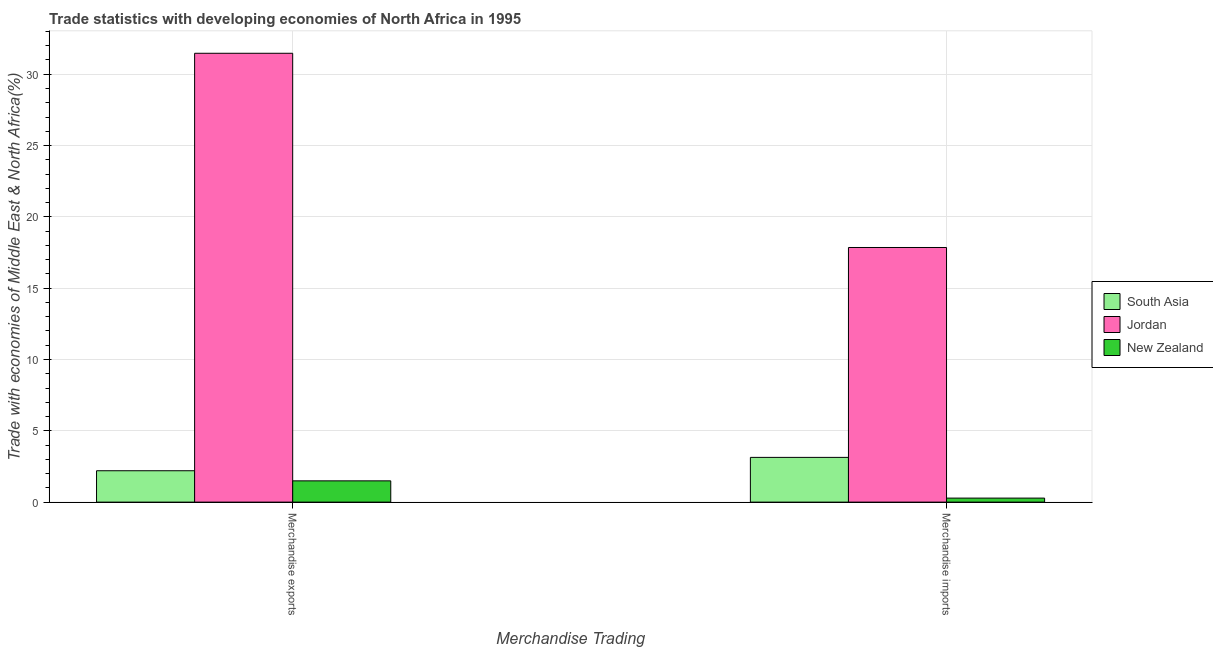Are the number of bars on each tick of the X-axis equal?
Give a very brief answer. Yes. How many bars are there on the 1st tick from the left?
Your response must be concise. 3. How many bars are there on the 1st tick from the right?
Offer a terse response. 3. What is the merchandise exports in Jordan?
Your answer should be compact. 31.47. Across all countries, what is the maximum merchandise imports?
Provide a short and direct response. 17.85. Across all countries, what is the minimum merchandise exports?
Ensure brevity in your answer.  1.49. In which country was the merchandise exports maximum?
Your answer should be compact. Jordan. In which country was the merchandise exports minimum?
Make the answer very short. New Zealand. What is the total merchandise exports in the graph?
Make the answer very short. 35.16. What is the difference between the merchandise exports in New Zealand and that in South Asia?
Provide a short and direct response. -0.71. What is the difference between the merchandise exports in South Asia and the merchandise imports in New Zealand?
Make the answer very short. 1.92. What is the average merchandise exports per country?
Keep it short and to the point. 11.72. What is the difference between the merchandise imports and merchandise exports in South Asia?
Your response must be concise. 0.94. In how many countries, is the merchandise imports greater than 11 %?
Offer a terse response. 1. What is the ratio of the merchandise exports in South Asia to that in Jordan?
Provide a succinct answer. 0.07. In how many countries, is the merchandise imports greater than the average merchandise imports taken over all countries?
Offer a very short reply. 1. What does the 3rd bar from the left in Merchandise exports represents?
Your answer should be compact. New Zealand. How many countries are there in the graph?
Offer a terse response. 3. What is the difference between two consecutive major ticks on the Y-axis?
Your answer should be very brief. 5. Does the graph contain any zero values?
Provide a succinct answer. No. Where does the legend appear in the graph?
Offer a very short reply. Center right. How are the legend labels stacked?
Your answer should be compact. Vertical. What is the title of the graph?
Offer a terse response. Trade statistics with developing economies of North Africa in 1995. What is the label or title of the X-axis?
Make the answer very short. Merchandise Trading. What is the label or title of the Y-axis?
Your answer should be very brief. Trade with economies of Middle East & North Africa(%). What is the Trade with economies of Middle East & North Africa(%) of South Asia in Merchandise exports?
Offer a terse response. 2.2. What is the Trade with economies of Middle East & North Africa(%) in Jordan in Merchandise exports?
Your answer should be very brief. 31.47. What is the Trade with economies of Middle East & North Africa(%) in New Zealand in Merchandise exports?
Provide a short and direct response. 1.49. What is the Trade with economies of Middle East & North Africa(%) in South Asia in Merchandise imports?
Provide a short and direct response. 3.14. What is the Trade with economies of Middle East & North Africa(%) in Jordan in Merchandise imports?
Your response must be concise. 17.85. What is the Trade with economies of Middle East & North Africa(%) in New Zealand in Merchandise imports?
Offer a very short reply. 0.28. Across all Merchandise Trading, what is the maximum Trade with economies of Middle East & North Africa(%) in South Asia?
Offer a very short reply. 3.14. Across all Merchandise Trading, what is the maximum Trade with economies of Middle East & North Africa(%) of Jordan?
Offer a very short reply. 31.47. Across all Merchandise Trading, what is the maximum Trade with economies of Middle East & North Africa(%) in New Zealand?
Give a very brief answer. 1.49. Across all Merchandise Trading, what is the minimum Trade with economies of Middle East & North Africa(%) of South Asia?
Keep it short and to the point. 2.2. Across all Merchandise Trading, what is the minimum Trade with economies of Middle East & North Africa(%) of Jordan?
Give a very brief answer. 17.85. Across all Merchandise Trading, what is the minimum Trade with economies of Middle East & North Africa(%) of New Zealand?
Offer a terse response. 0.28. What is the total Trade with economies of Middle East & North Africa(%) in South Asia in the graph?
Your answer should be very brief. 5.34. What is the total Trade with economies of Middle East & North Africa(%) of Jordan in the graph?
Your answer should be very brief. 49.32. What is the total Trade with economies of Middle East & North Africa(%) of New Zealand in the graph?
Offer a terse response. 1.77. What is the difference between the Trade with economies of Middle East & North Africa(%) in South Asia in Merchandise exports and that in Merchandise imports?
Provide a succinct answer. -0.94. What is the difference between the Trade with economies of Middle East & North Africa(%) in Jordan in Merchandise exports and that in Merchandise imports?
Offer a terse response. 13.62. What is the difference between the Trade with economies of Middle East & North Africa(%) in New Zealand in Merchandise exports and that in Merchandise imports?
Ensure brevity in your answer.  1.21. What is the difference between the Trade with economies of Middle East & North Africa(%) in South Asia in Merchandise exports and the Trade with economies of Middle East & North Africa(%) in Jordan in Merchandise imports?
Your answer should be very brief. -15.65. What is the difference between the Trade with economies of Middle East & North Africa(%) of South Asia in Merchandise exports and the Trade with economies of Middle East & North Africa(%) of New Zealand in Merchandise imports?
Your answer should be compact. 1.92. What is the difference between the Trade with economies of Middle East & North Africa(%) of Jordan in Merchandise exports and the Trade with economies of Middle East & North Africa(%) of New Zealand in Merchandise imports?
Provide a short and direct response. 31.19. What is the average Trade with economies of Middle East & North Africa(%) of South Asia per Merchandise Trading?
Your answer should be compact. 2.67. What is the average Trade with economies of Middle East & North Africa(%) in Jordan per Merchandise Trading?
Provide a succinct answer. 24.66. What is the average Trade with economies of Middle East & North Africa(%) of New Zealand per Merchandise Trading?
Your answer should be compact. 0.89. What is the difference between the Trade with economies of Middle East & North Africa(%) in South Asia and Trade with economies of Middle East & North Africa(%) in Jordan in Merchandise exports?
Give a very brief answer. -29.27. What is the difference between the Trade with economies of Middle East & North Africa(%) of South Asia and Trade with economies of Middle East & North Africa(%) of New Zealand in Merchandise exports?
Offer a terse response. 0.71. What is the difference between the Trade with economies of Middle East & North Africa(%) in Jordan and Trade with economies of Middle East & North Africa(%) in New Zealand in Merchandise exports?
Your response must be concise. 29.98. What is the difference between the Trade with economies of Middle East & North Africa(%) of South Asia and Trade with economies of Middle East & North Africa(%) of Jordan in Merchandise imports?
Offer a very short reply. -14.72. What is the difference between the Trade with economies of Middle East & North Africa(%) of South Asia and Trade with economies of Middle East & North Africa(%) of New Zealand in Merchandise imports?
Give a very brief answer. 2.86. What is the difference between the Trade with economies of Middle East & North Africa(%) of Jordan and Trade with economies of Middle East & North Africa(%) of New Zealand in Merchandise imports?
Make the answer very short. 17.57. What is the ratio of the Trade with economies of Middle East & North Africa(%) in South Asia in Merchandise exports to that in Merchandise imports?
Provide a succinct answer. 0.7. What is the ratio of the Trade with economies of Middle East & North Africa(%) of Jordan in Merchandise exports to that in Merchandise imports?
Ensure brevity in your answer.  1.76. What is the ratio of the Trade with economies of Middle East & North Africa(%) of New Zealand in Merchandise exports to that in Merchandise imports?
Make the answer very short. 5.29. What is the difference between the highest and the second highest Trade with economies of Middle East & North Africa(%) of South Asia?
Your answer should be very brief. 0.94. What is the difference between the highest and the second highest Trade with economies of Middle East & North Africa(%) of Jordan?
Provide a succinct answer. 13.62. What is the difference between the highest and the second highest Trade with economies of Middle East & North Africa(%) of New Zealand?
Give a very brief answer. 1.21. What is the difference between the highest and the lowest Trade with economies of Middle East & North Africa(%) of South Asia?
Your answer should be compact. 0.94. What is the difference between the highest and the lowest Trade with economies of Middle East & North Africa(%) in Jordan?
Provide a short and direct response. 13.62. What is the difference between the highest and the lowest Trade with economies of Middle East & North Africa(%) in New Zealand?
Your answer should be very brief. 1.21. 